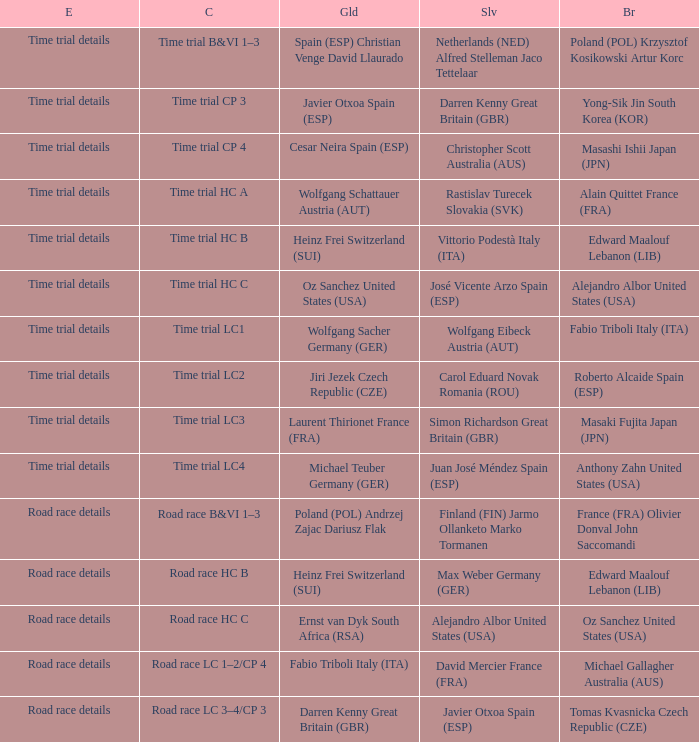What is the event when gold is darren kenny great britain (gbr)? Road race details. 